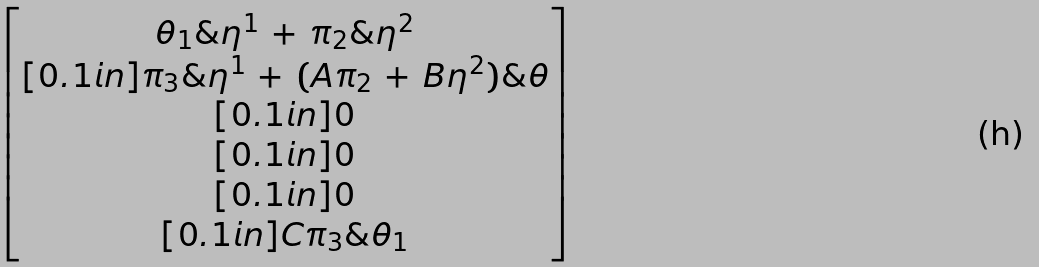Convert formula to latex. <formula><loc_0><loc_0><loc_500><loc_500>\begin{bmatrix} \theta _ { 1 } \& \eta ^ { 1 } \, + \, \pi _ { 2 } \& \eta ^ { 2 } \\ [ 0 . 1 i n ] \pi _ { 3 } \& \eta ^ { 1 } \, + \, ( A \pi _ { 2 } \, + \, B \eta ^ { 2 } ) \& \theta \\ [ 0 . 1 i n ] 0 \\ [ 0 . 1 i n ] 0 \\ [ 0 . 1 i n ] 0 \\ [ 0 . 1 i n ] C \pi _ { 3 } \& \theta _ { 1 } \end{bmatrix}</formula> 